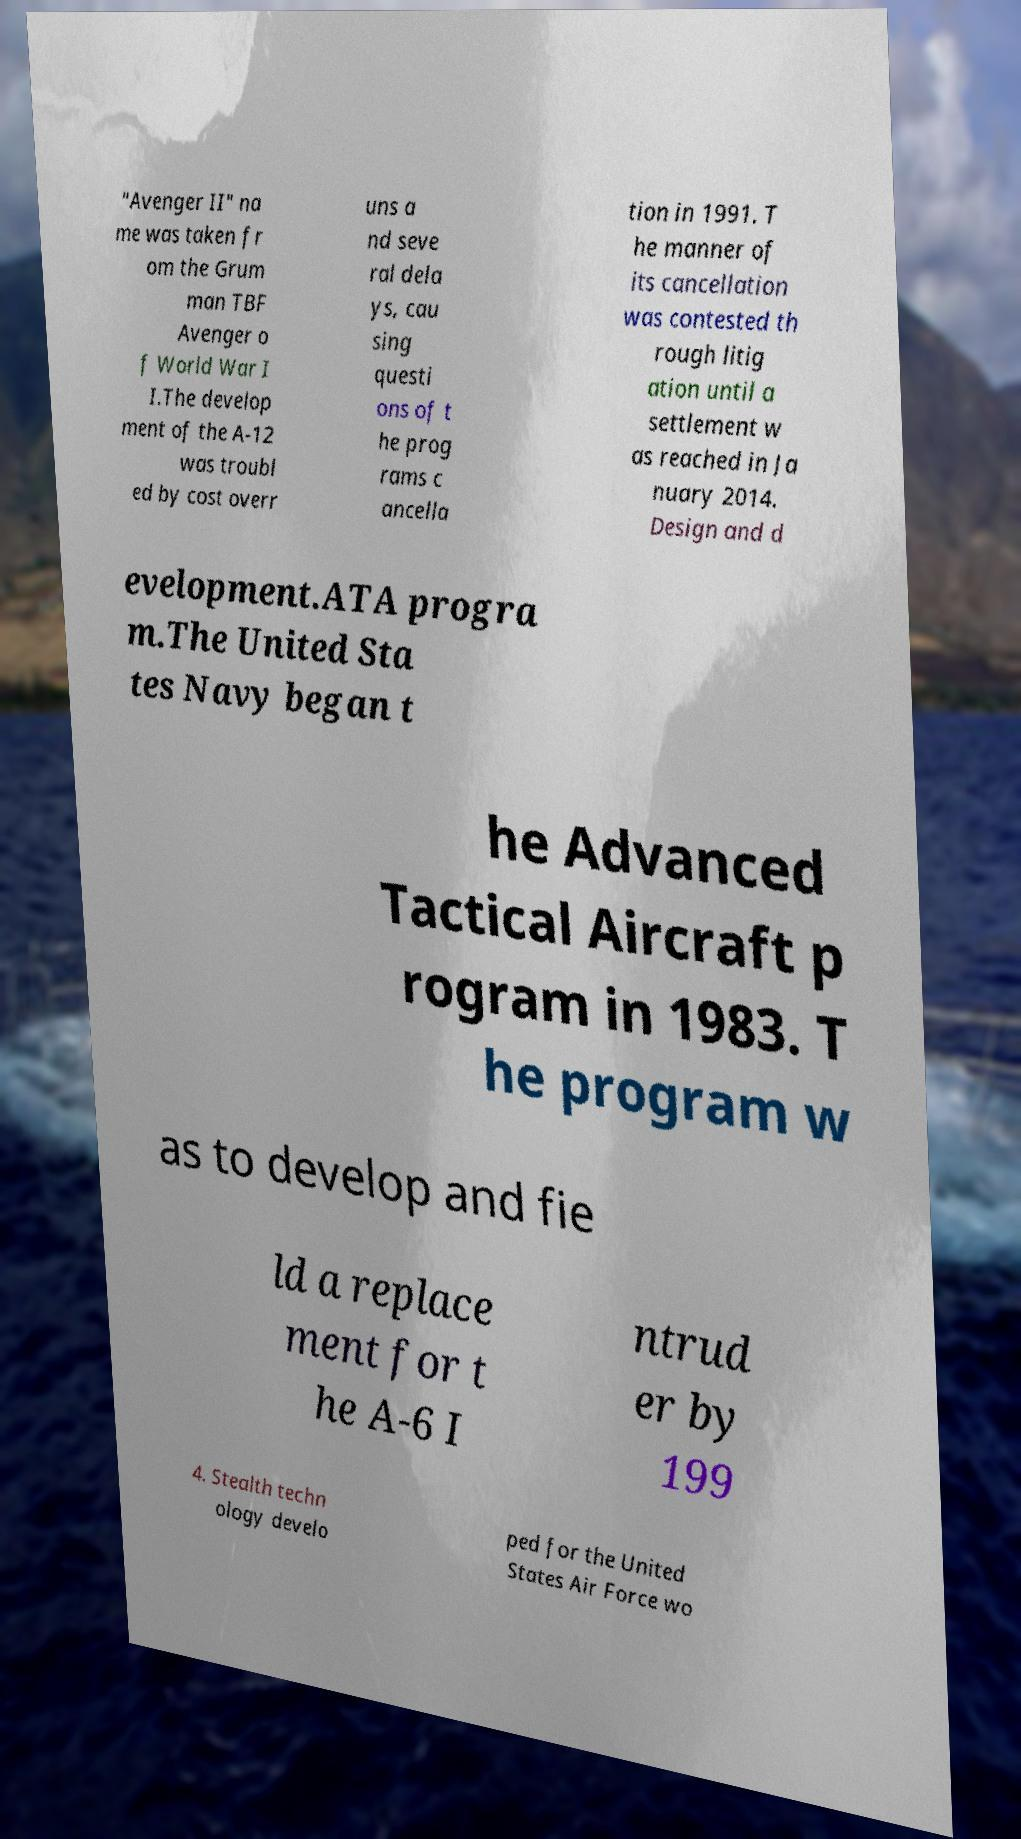Please identify and transcribe the text found in this image. "Avenger II" na me was taken fr om the Grum man TBF Avenger o f World War I I.The develop ment of the A-12 was troubl ed by cost overr uns a nd seve ral dela ys, cau sing questi ons of t he prog rams c ancella tion in 1991. T he manner of its cancellation was contested th rough litig ation until a settlement w as reached in Ja nuary 2014. Design and d evelopment.ATA progra m.The United Sta tes Navy began t he Advanced Tactical Aircraft p rogram in 1983. T he program w as to develop and fie ld a replace ment for t he A-6 I ntrud er by 199 4. Stealth techn ology develo ped for the United States Air Force wo 